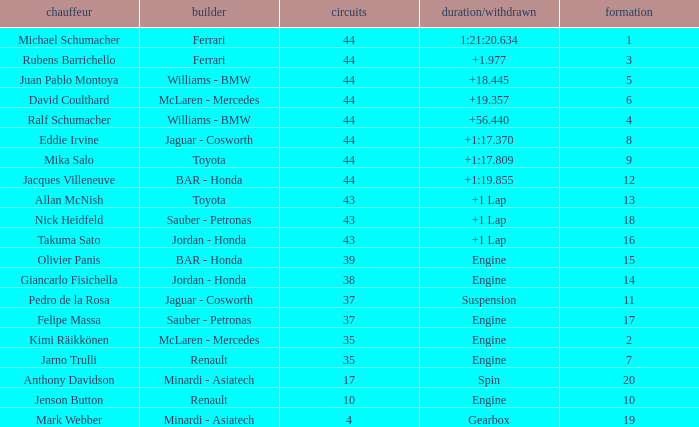What was the time of the driver on grid 3? 1.977. 